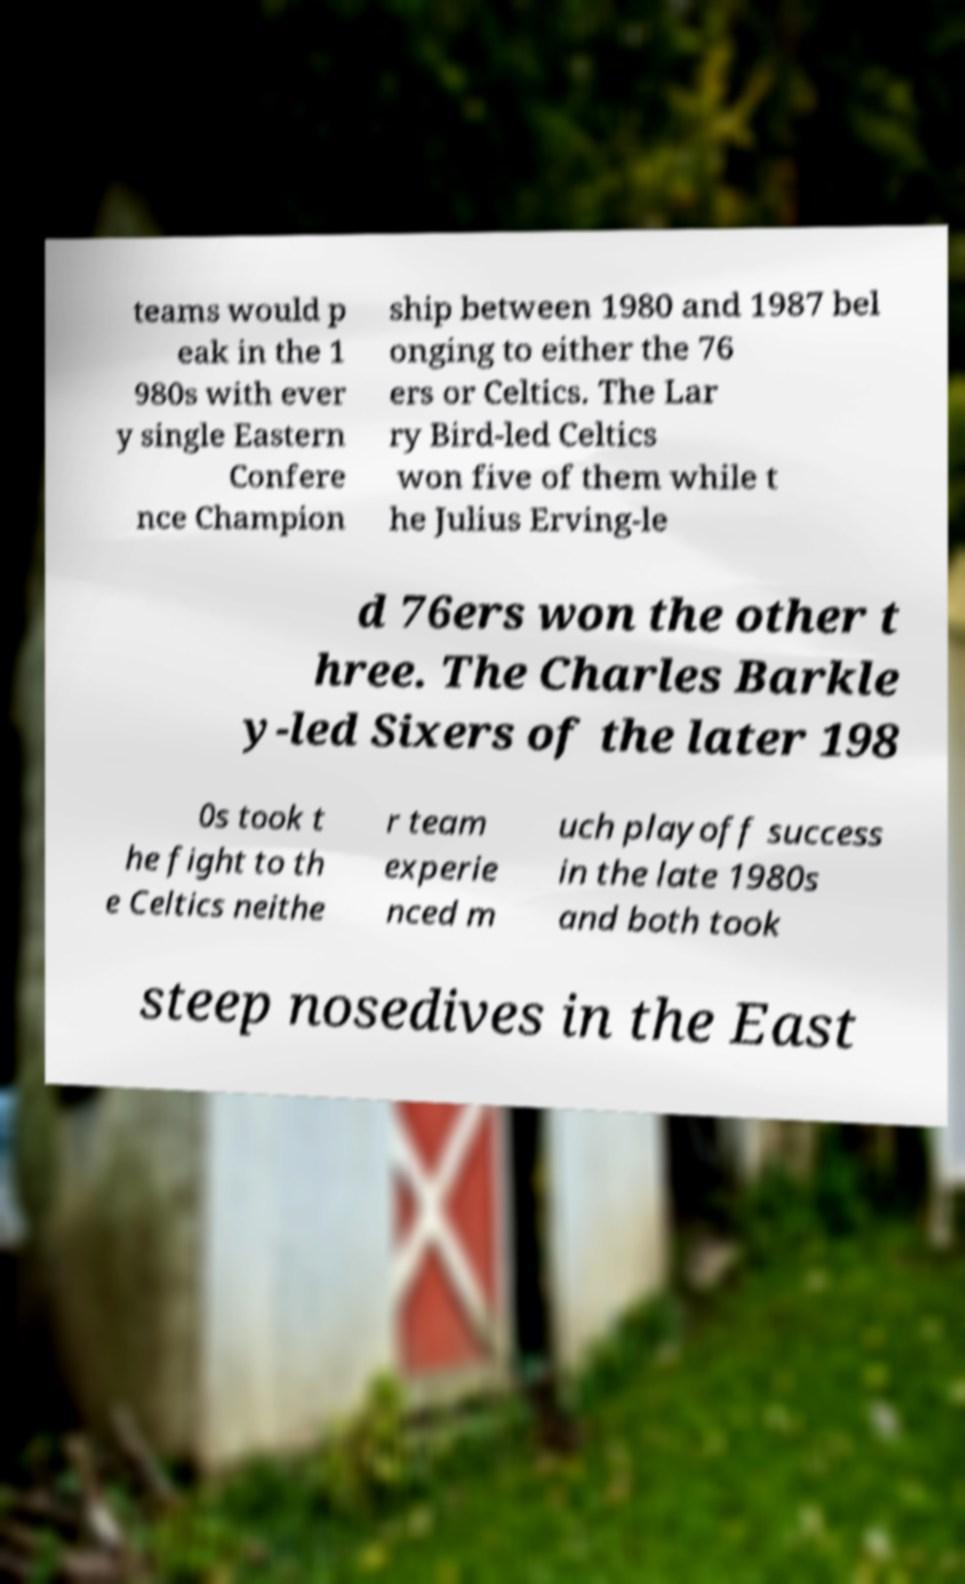What messages or text are displayed in this image? I need them in a readable, typed format. teams would p eak in the 1 980s with ever y single Eastern Confere nce Champion ship between 1980 and 1987 bel onging to either the 76 ers or Celtics. The Lar ry Bird-led Celtics won five of them while t he Julius Erving-le d 76ers won the other t hree. The Charles Barkle y-led Sixers of the later 198 0s took t he fight to th e Celtics neithe r team experie nced m uch playoff success in the late 1980s and both took steep nosedives in the East 